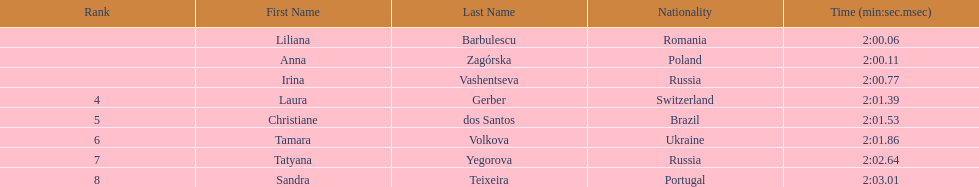What was the time difference between the first place finisher and the eighth place finisher? 2.95. 